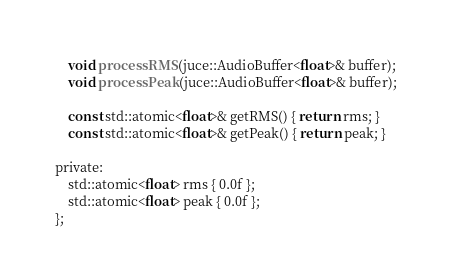<code> <loc_0><loc_0><loc_500><loc_500><_C_>    void processRMS (juce::AudioBuffer<float>& buffer);
    void processPeak (juce::AudioBuffer<float>& buffer);
    
    const std::atomic<float>& getRMS() { return rms; }
    const std::atomic<float>& getPeak() { return peak; }
    
private:
    std::atomic<float> rms { 0.0f };
    std::atomic<float> peak { 0.0f };
};
</code> 